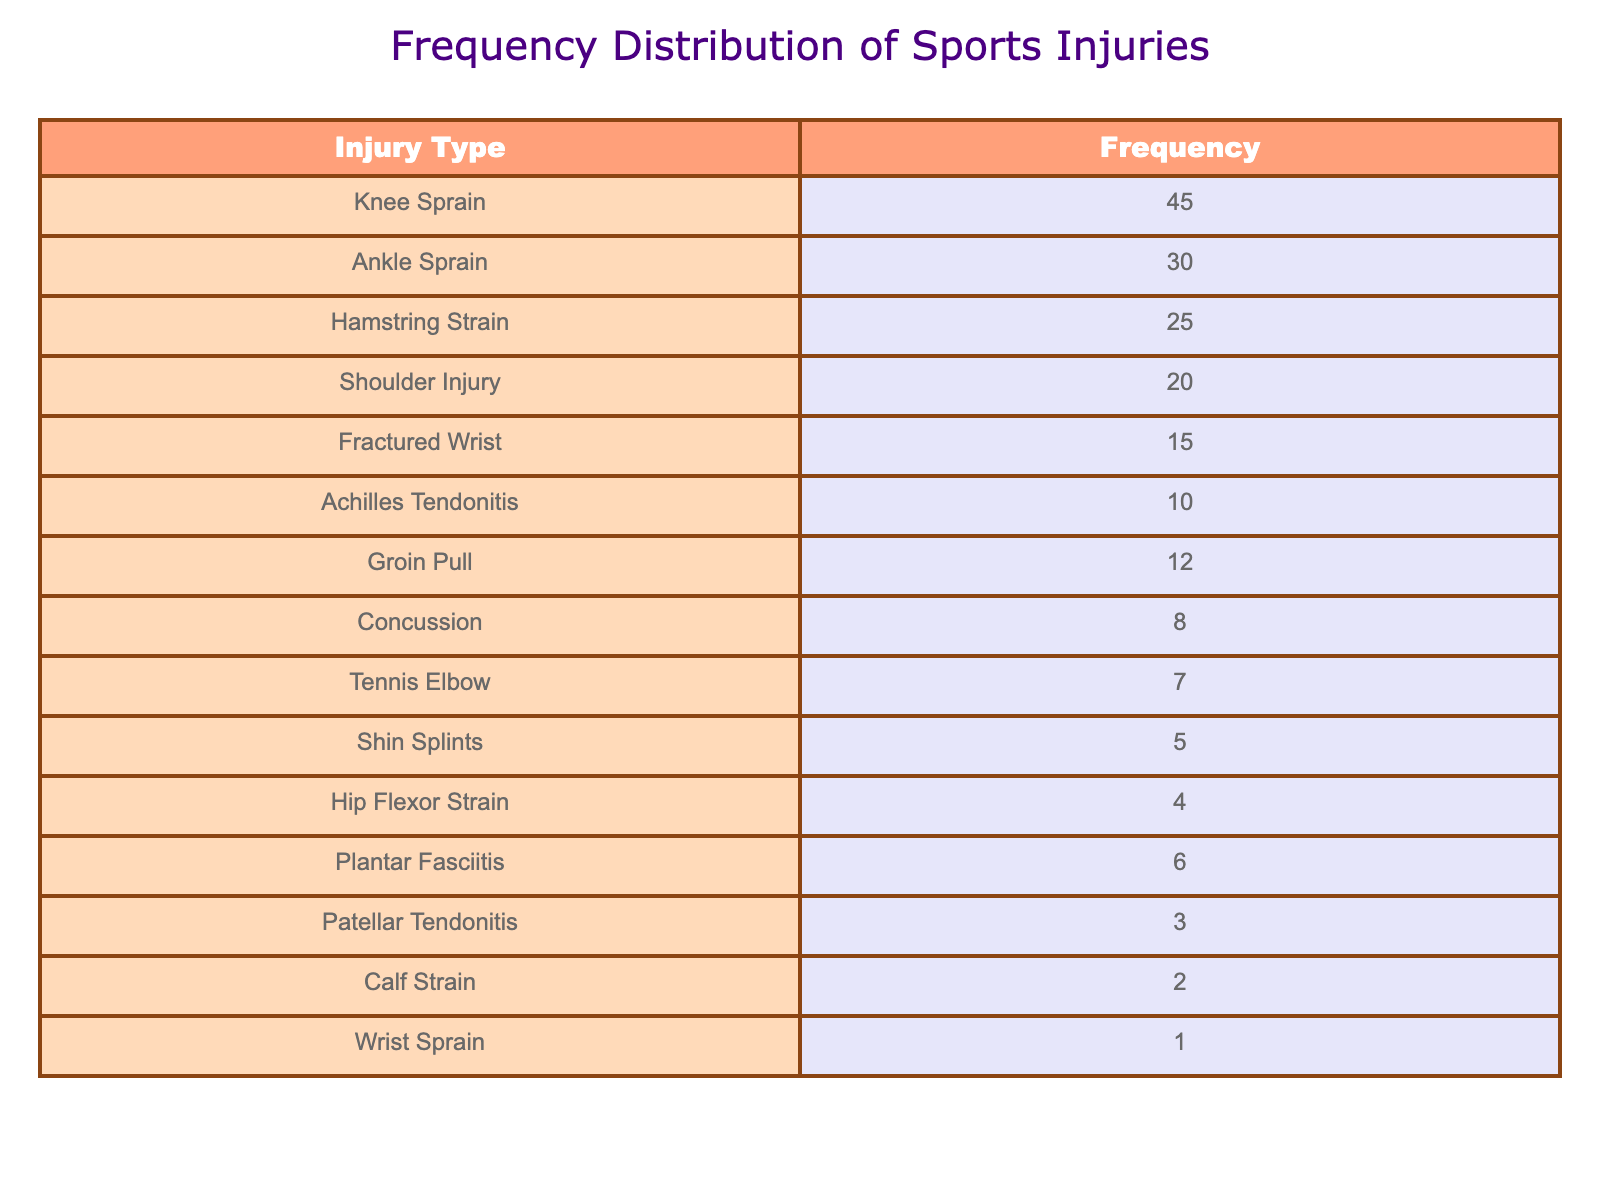What is the most frequently reported type of sports injury? The highest frequency in the table is for Knee Sprain, which has a frequency of 45. Therefore, it is the most frequently reported injury.
Answer: Knee Sprain How many injuries are reported in total? To find the total number of injuries, sum the frequencies from all injury types: 45 + 30 + 25 + 20 + 15 + 10 + 12 + 8 + 7 + 5 + 4 + 6 + 3 + 2 + 1 = 218.
Answer: 218 Is the number of reported Shoulder Injuries greater than the number of reported Fractured Wrists? The frequency for Shoulder Injury is 20, and for Fractured Wrist is 15. Since 20 is greater than 15, the statement is true.
Answer: Yes What percentage of total injuries does Concussion represent? Concussion has a frequency of 8. First, compute the percentage: (8 / 218) * 100 = approximately 3.67%.
Answer: 3.67% What is the difference in frequency between Ankle Sprain and Hip Flexor Strain? Ankle Sprain has a frequency of 30, while Hip Flexor Strain has a frequency of 4. The difference is calculated as 30 - 4 = 26.
Answer: 26 Which injury types have a frequency of 10 or less? The injury types with a frequency of 10 or less are: Achilles Tendonitis (10), Shin Splints (5), Hip Flexor Strain (4), Patellar Tendonitis (3), Calf Strain (2), and Wrist Sprain (1).
Answer: 6 types If you combine the frequencies of Hamstring Strain and Groin Pull, how does it compare to the frequency of Ankle Sprain? Hamstring Strain has a frequency of 25 and Groin Pull has 12. Combine these: 25 + 12 = 37. Ankle Sprain has a frequency of 30. Since 37 is greater than 30, the combined frequency is higher.
Answer: Yes What is the average frequency of all reported injuries? To find the average, sum all the frequencies (total 218) and divide by the number of injury types (15): 218 / 15 = approximately 14.53.
Answer: 14.53 Are there more cases of Tennis Elbow than Calf Strain? Tennis Elbow has a frequency of 7, and Calf Strain has a frequency of 2. Since 7 is greater than 2, Tennis Elbow is reported more frequently.
Answer: Yes 